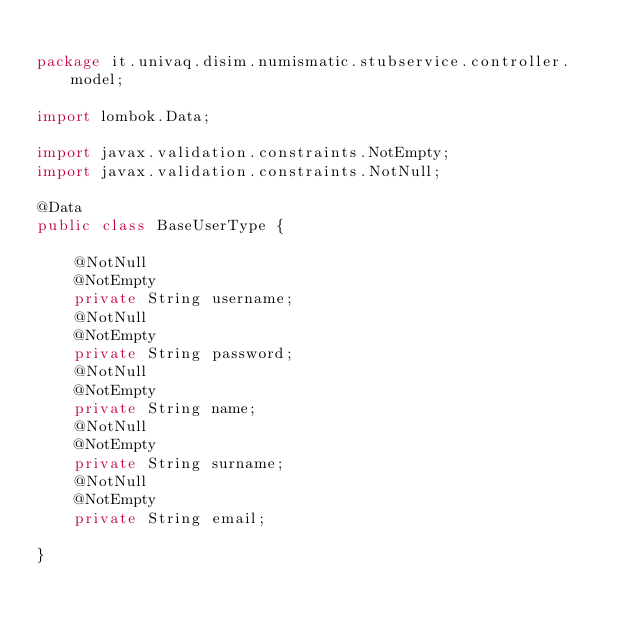<code> <loc_0><loc_0><loc_500><loc_500><_Java_>
package it.univaq.disim.numismatic.stubservice.controller.model;

import lombok.Data;

import javax.validation.constraints.NotEmpty;
import javax.validation.constraints.NotNull;

@Data
public class BaseUserType {

    @NotNull
    @NotEmpty
    private String username;
    @NotNull
    @NotEmpty
    private String password;
    @NotNull
    @NotEmpty
    private String name;
    @NotNull
    @NotEmpty
    private String surname;
    @NotNull
    @NotEmpty
    private String email;

}
</code> 